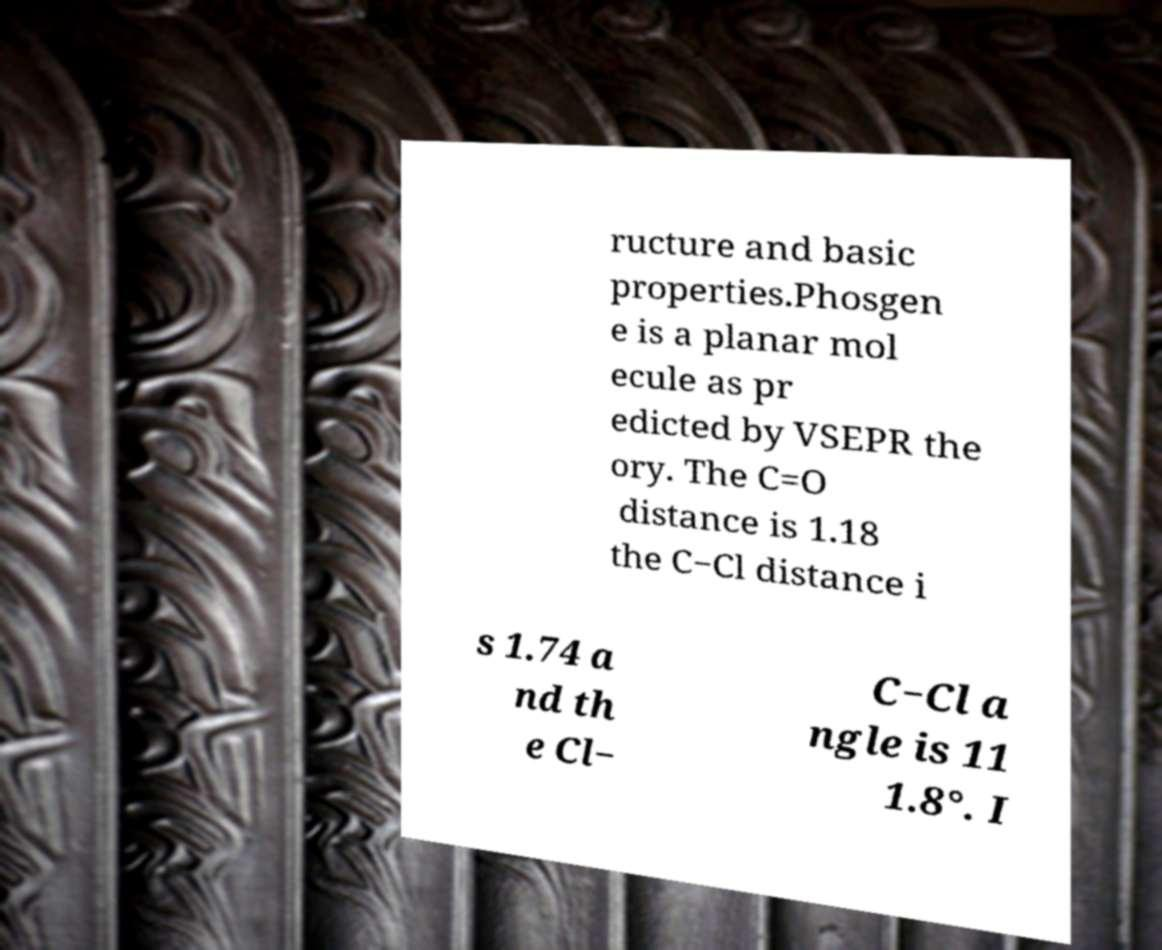I need the written content from this picture converted into text. Can you do that? ructure and basic properties.Phosgen e is a planar mol ecule as pr edicted by VSEPR the ory. The C=O distance is 1.18 the C−Cl distance i s 1.74 a nd th e Cl− C−Cl a ngle is 11 1.8°. I 